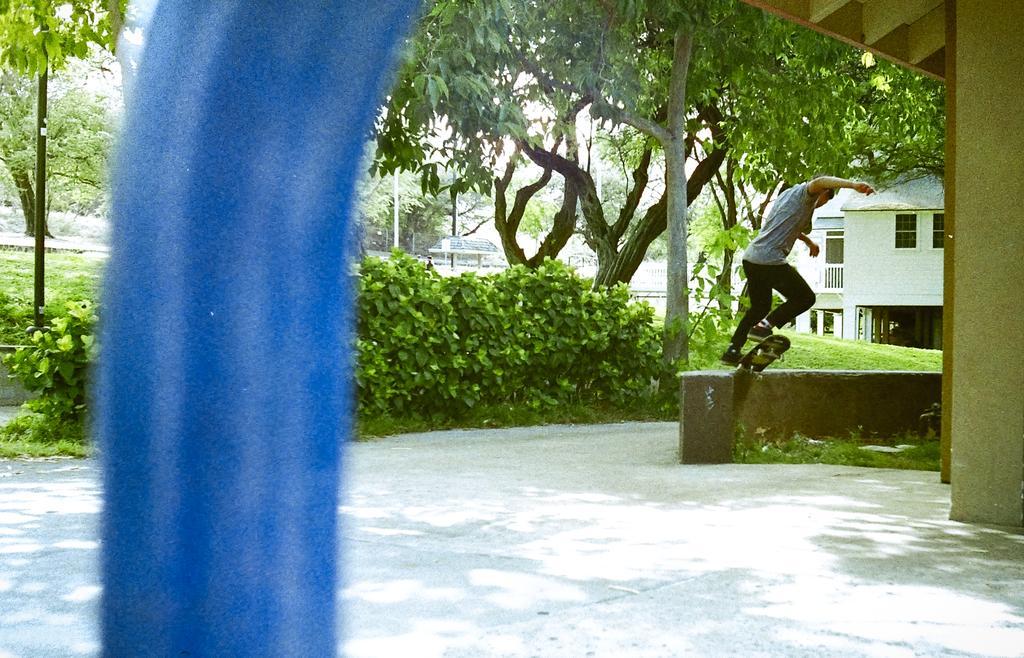How would you summarize this image in a sentence or two? In this image I can see a blue colored object, the ground, a person skateboarding, few plants, few trees and few buildings. 